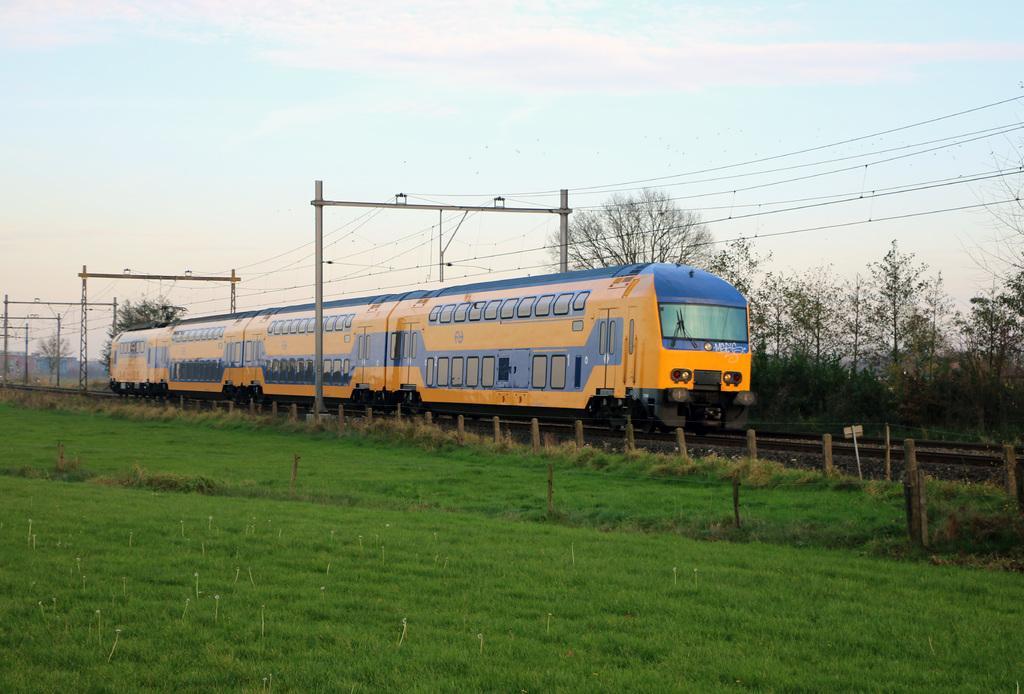Describe this image in one or two sentences. In this image we can see a locomotive on the track, stones, barrier poles, grass, trees, electric poles, electric cables and sky with clouds in the background. 